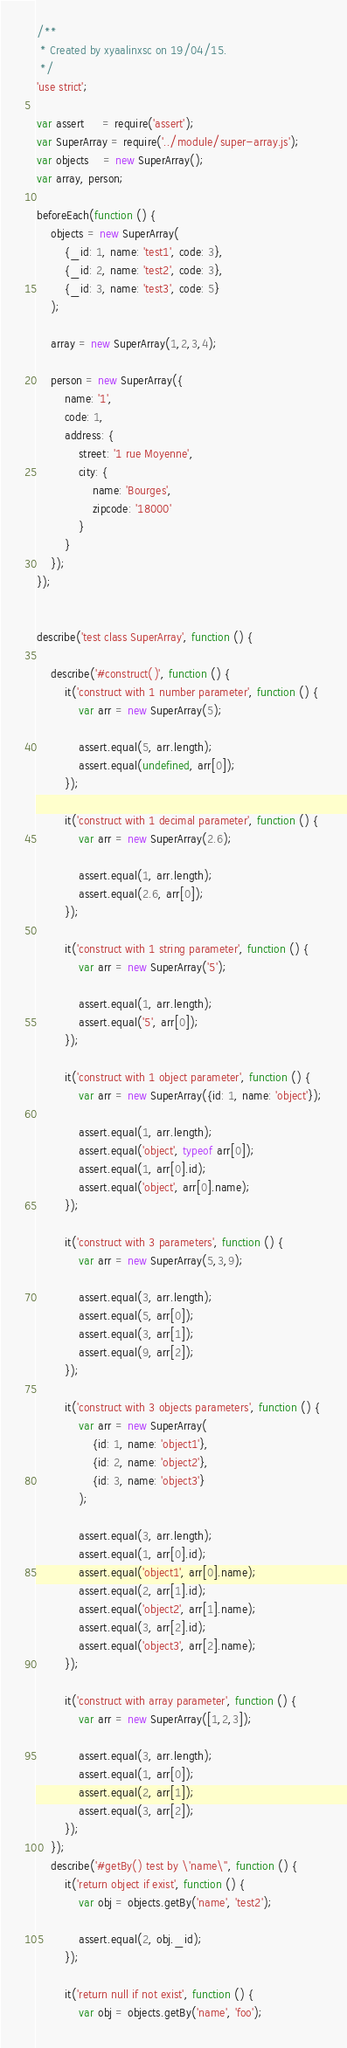<code> <loc_0><loc_0><loc_500><loc_500><_JavaScript_>/**
 * Created by xyaalinxsc on 19/04/15.
 */
'use strict';

var assert     = require('assert');
var SuperArray = require('../module/super-array.js');
var objects    = new SuperArray();
var array, person;

beforeEach(function () {
    objects = new SuperArray(
        {_id: 1, name: 'test1', code: 3},
        {_id: 2, name: 'test2', code: 3},
        {_id: 3, name: 'test3', code: 5}
    );

    array = new SuperArray(1,2,3,4);

    person = new SuperArray({
        name: '1',
        code: 1,
        address: {
            street: '1 rue Moyenne',
            city: {
                name: 'Bourges',
                zipcode: '18000'
            }
        }
    });
});


describe('test class SuperArray', function () {

    describe('#construct()', function () {
        it('construct with 1 number parameter', function () {
            var arr = new SuperArray(5);

            assert.equal(5, arr.length);
            assert.equal(undefined, arr[0]);
        });

        it('construct with 1 decimal parameter', function () {
            var arr = new SuperArray(2.6);

            assert.equal(1, arr.length);
            assert.equal(2.6, arr[0]);
        });

        it('construct with 1 string parameter', function () {
            var arr = new SuperArray('5');

            assert.equal(1, arr.length);
            assert.equal('5', arr[0]);
        });

        it('construct with 1 object parameter', function () {
            var arr = new SuperArray({id: 1, name: 'object'});

            assert.equal(1, arr.length);
            assert.equal('object', typeof arr[0]);
            assert.equal(1, arr[0].id);
            assert.equal('object', arr[0].name);
        });

        it('construct with 3 parameters', function () {
            var arr = new SuperArray(5,3,9);

            assert.equal(3, arr.length);
            assert.equal(5, arr[0]);
            assert.equal(3, arr[1]);
            assert.equal(9, arr[2]);
        });

        it('construct with 3 objects parameters', function () {
            var arr = new SuperArray(
                {id: 1, name: 'object1'},
                {id: 2, name: 'object2'},
                {id: 3, name: 'object3'}
            );

            assert.equal(3, arr.length);
            assert.equal(1, arr[0].id);
            assert.equal('object1', arr[0].name);
            assert.equal(2, arr[1].id);
            assert.equal('object2', arr[1].name);
            assert.equal(3, arr[2].id);
            assert.equal('object3', arr[2].name);
        });

        it('construct with array parameter', function () {
            var arr = new SuperArray([1,2,3]);

            assert.equal(3, arr.length);
            assert.equal(1, arr[0]);
            assert.equal(2, arr[1]);
            assert.equal(3, arr[2]);
        });
    });
    describe('#getBy() test by \'name\'', function () {
        it('return object if exist', function () {
            var obj = objects.getBy('name', 'test2');

            assert.equal(2, obj._id);
        });

        it('return null if not exist', function () {
            var obj = objects.getBy('name', 'foo');
</code> 